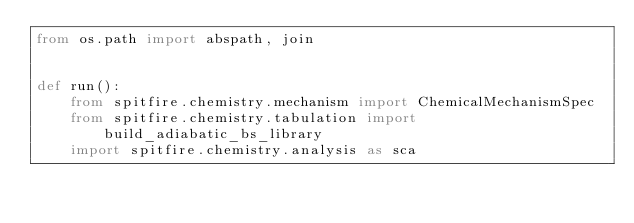<code> <loc_0><loc_0><loc_500><loc_500><_Python_>from os.path import abspath, join


def run():
    from spitfire.chemistry.mechanism import ChemicalMechanismSpec
    from spitfire.chemistry.tabulation import build_adiabatic_bs_library
    import spitfire.chemistry.analysis as sca
</code> 